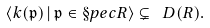<formula> <loc_0><loc_0><loc_500><loc_500>\langle k ( \mathfrak { p } ) \, | \, \mathfrak { p } \in \S p e c R \rangle \subsetneq \ D ( R ) .</formula> 